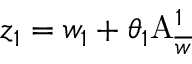Convert formula to latex. <formula><loc_0><loc_0><loc_500><loc_500>z _ { 1 } = w _ { 1 } + \theta _ { 1 } A _ { \overline { w } } ^ { 1 }</formula> 